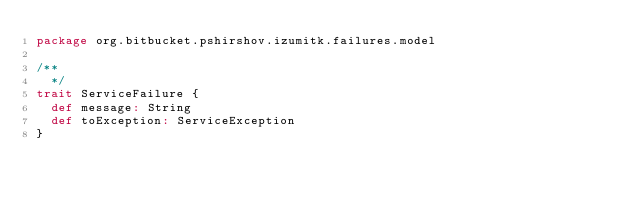<code> <loc_0><loc_0><loc_500><loc_500><_Scala_>package org.bitbucket.pshirshov.izumitk.failures.model

/**
  */
trait ServiceFailure {
  def message: String
  def toException: ServiceException
}


</code> 